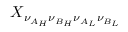Convert formula to latex. <formula><loc_0><loc_0><loc_500><loc_500>X _ { \nu _ { A _ { H } } \nu _ { B _ { H } } \nu _ { A _ { L } } \nu _ { B _ { L } } }</formula> 